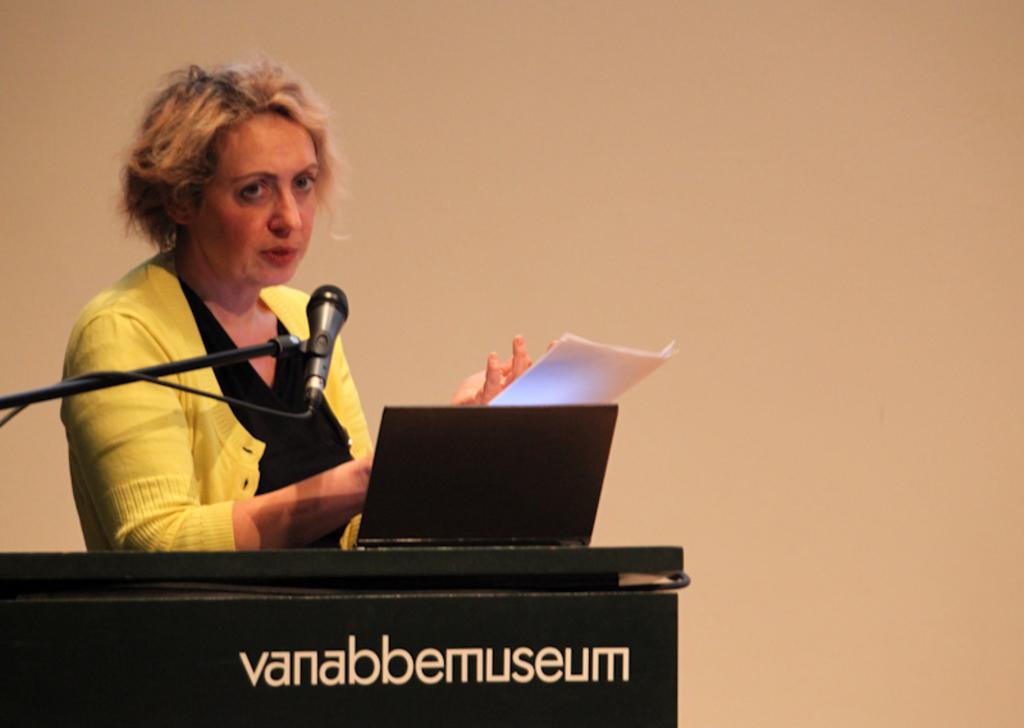How would you summarize this image in a sentence or two? In the picture we can see a woman standing near the desk and talking into the microphone and on the desk, we can see a laptop and she is in yellow coat and black T-shirt and behind her we can see a wall which is cream in color. 